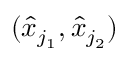<formula> <loc_0><loc_0><loc_500><loc_500>( \hat { x } _ { j _ { 1 } } , \hat { x } _ { j _ { 2 } } )</formula> 